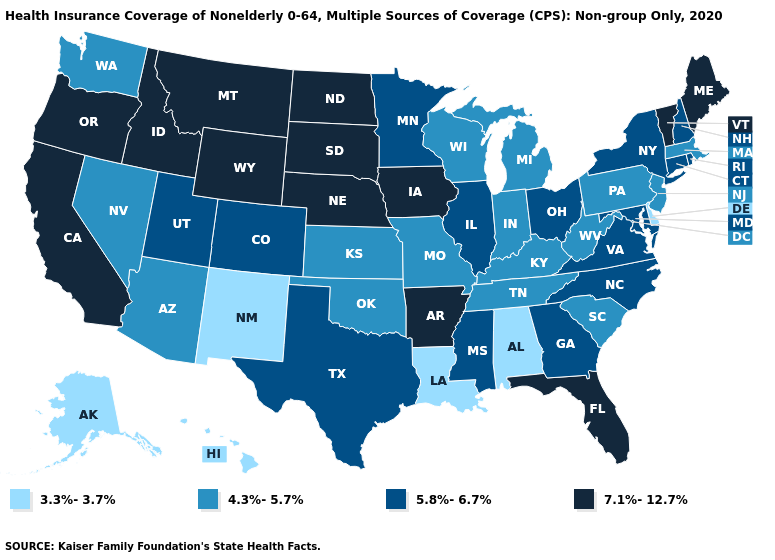What is the value of Rhode Island?
Quick response, please. 5.8%-6.7%. What is the value of Nevada?
Be succinct. 4.3%-5.7%. Does Arizona have the lowest value in the West?
Write a very short answer. No. Is the legend a continuous bar?
Give a very brief answer. No. What is the value of Michigan?
Concise answer only. 4.3%-5.7%. Among the states that border Oregon , which have the highest value?
Give a very brief answer. California, Idaho. Does Maine have a higher value than Indiana?
Be succinct. Yes. Does the first symbol in the legend represent the smallest category?
Write a very short answer. Yes. Does the map have missing data?
Concise answer only. No. Name the states that have a value in the range 5.8%-6.7%?
Give a very brief answer. Colorado, Connecticut, Georgia, Illinois, Maryland, Minnesota, Mississippi, New Hampshire, New York, North Carolina, Ohio, Rhode Island, Texas, Utah, Virginia. Name the states that have a value in the range 7.1%-12.7%?
Write a very short answer. Arkansas, California, Florida, Idaho, Iowa, Maine, Montana, Nebraska, North Dakota, Oregon, South Dakota, Vermont, Wyoming. Does the map have missing data?
Write a very short answer. No. What is the value of Kentucky?
Short answer required. 4.3%-5.7%. Name the states that have a value in the range 5.8%-6.7%?
Keep it brief. Colorado, Connecticut, Georgia, Illinois, Maryland, Minnesota, Mississippi, New Hampshire, New York, North Carolina, Ohio, Rhode Island, Texas, Utah, Virginia. What is the lowest value in states that border New Mexico?
Answer briefly. 4.3%-5.7%. 